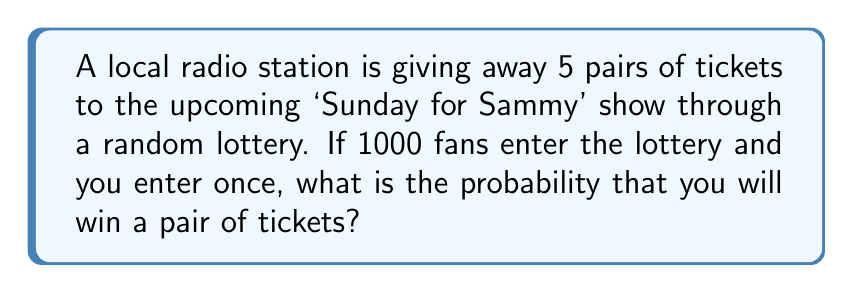Can you answer this question? Let's approach this step-by-step:

1) First, we need to identify the probability of winning. There are 5 pairs of tickets available, and 1000 people have entered the lottery.

2) The probability of winning can be calculated as:

   $P(\text{winning}) = \frac{\text{number of favorable outcomes}}{\text{total number of possible outcomes}}$

3) In this case:
   - Number of favorable outcomes = 5 (as there are 5 pairs of tickets)
   - Total number of possible outcomes = 1000 (as 1000 people entered)

4) So, we can calculate:

   $P(\text{winning}) = \frac{5}{1000} = \frac{1}{200} = 0.005$

5) To convert this to a percentage, we multiply by 100:

   $0.005 \times 100 = 0.5\%$

Therefore, the probability of winning a pair of tickets is 0.005 or 0.5%.
Answer: $\frac{1}{200}$ or $0.005$ or $0.5\%$ 